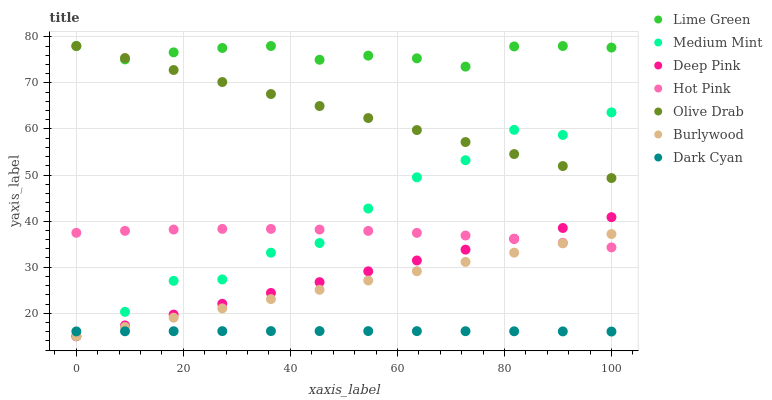Does Dark Cyan have the minimum area under the curve?
Answer yes or no. Yes. Does Lime Green have the maximum area under the curve?
Answer yes or no. Yes. Does Deep Pink have the minimum area under the curve?
Answer yes or no. No. Does Deep Pink have the maximum area under the curve?
Answer yes or no. No. Is Burlywood the smoothest?
Answer yes or no. Yes. Is Medium Mint the roughest?
Answer yes or no. Yes. Is Deep Pink the smoothest?
Answer yes or no. No. Is Deep Pink the roughest?
Answer yes or no. No. Does Medium Mint have the lowest value?
Answer yes or no. Yes. Does Hot Pink have the lowest value?
Answer yes or no. No. Does Olive Drab have the highest value?
Answer yes or no. Yes. Does Deep Pink have the highest value?
Answer yes or no. No. Is Medium Mint less than Lime Green?
Answer yes or no. Yes. Is Olive Drab greater than Deep Pink?
Answer yes or no. Yes. Does Deep Pink intersect Medium Mint?
Answer yes or no. Yes. Is Deep Pink less than Medium Mint?
Answer yes or no. No. Is Deep Pink greater than Medium Mint?
Answer yes or no. No. Does Medium Mint intersect Lime Green?
Answer yes or no. No. 